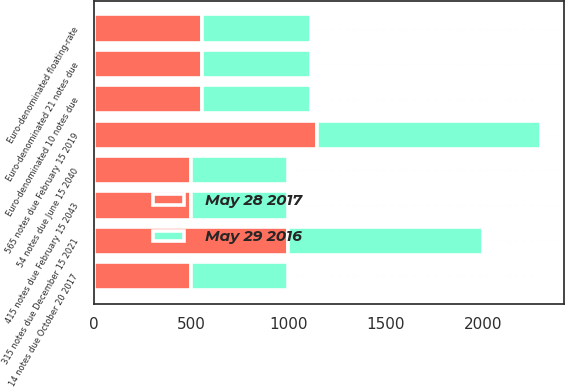Convert chart to OTSL. <chart><loc_0><loc_0><loc_500><loc_500><stacked_bar_chart><ecel><fcel>565 notes due February 15 2019<fcel>315 notes due December 15 2021<fcel>Euro-denominated 21 notes due<fcel>Euro-denominated 10 notes due<fcel>Euro-denominated floating-rate<fcel>14 notes due October 20 2017<fcel>54 notes due June 15 2040<fcel>415 notes due February 15 2043<nl><fcel>May 28 2017<fcel>1150<fcel>1000<fcel>559.2<fcel>559.2<fcel>559.2<fcel>500<fcel>500<fcel>500<nl><fcel>May 29 2016<fcel>1150<fcel>1000<fcel>555.8<fcel>555.8<fcel>555.8<fcel>500<fcel>500<fcel>500<nl></chart> 